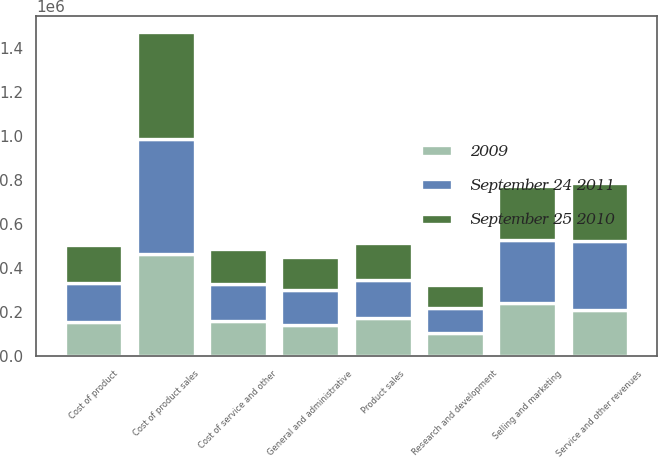<chart> <loc_0><loc_0><loc_500><loc_500><stacked_bar_chart><ecel><fcel>Product sales<fcel>Service and other revenues<fcel>Cost of product sales<fcel>Cost of product<fcel>Cost of service and other<fcel>Research and development<fcel>Selling and marketing<fcel>General and administrative<nl><fcel>September 24 2011<fcel>171447<fcel>311009<fcel>521189<fcel>177456<fcel>167523<fcel>116696<fcel>286730<fcel>158793<nl><fcel>September 25 2010<fcel>171447<fcel>264652<fcel>487057<fcel>171447<fcel>161060<fcel>104305<fcel>247374<fcel>148340<nl><fcel>2009<fcel>171447<fcel>210148<fcel>463066<fcel>155519<fcel>156998<fcel>102453<fcel>238977<fcel>140700<nl></chart> 